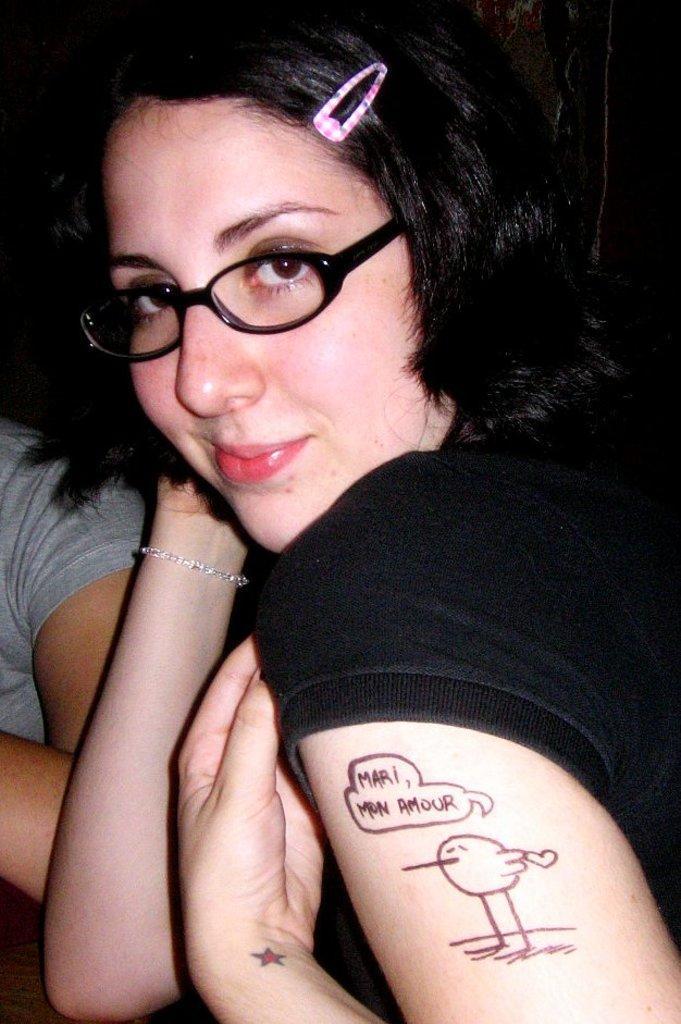Describe this image in one or two sentences. In this image there is a woman, she is wearing spectacles, there is text on her hand, there is a woman towards the left of the image, the background of the image is dark. 